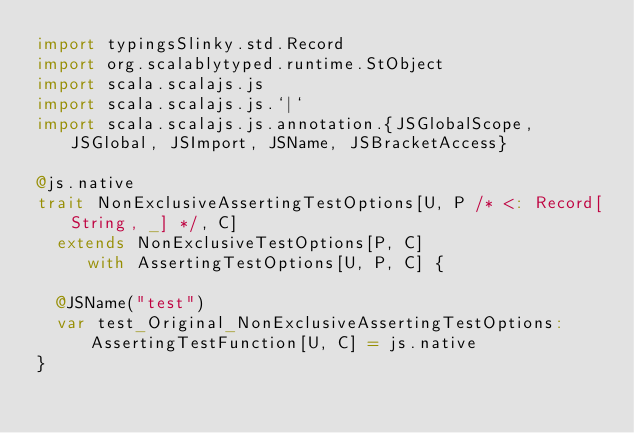Convert code to text. <code><loc_0><loc_0><loc_500><loc_500><_Scala_>import typingsSlinky.std.Record
import org.scalablytyped.runtime.StObject
import scala.scalajs.js
import scala.scalajs.js.`|`
import scala.scalajs.js.annotation.{JSGlobalScope, JSGlobal, JSImport, JSName, JSBracketAccess}

@js.native
trait NonExclusiveAssertingTestOptions[U, P /* <: Record[String, _] */, C]
  extends NonExclusiveTestOptions[P, C]
     with AssertingTestOptions[U, P, C] {
  
  @JSName("test")
  var test_Original_NonExclusiveAssertingTestOptions: AssertingTestFunction[U, C] = js.native
}
</code> 